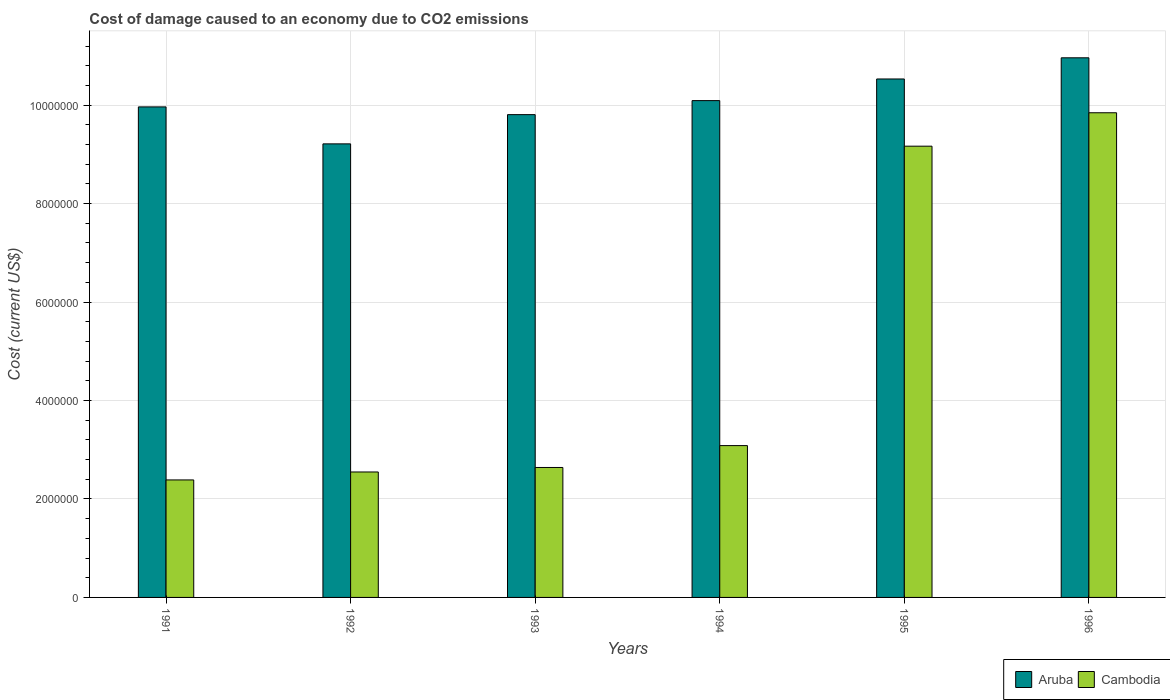How many different coloured bars are there?
Ensure brevity in your answer.  2. What is the label of the 1st group of bars from the left?
Provide a succinct answer. 1991. In how many cases, is the number of bars for a given year not equal to the number of legend labels?
Provide a short and direct response. 0. What is the cost of damage caused due to CO2 emissisons in Aruba in 1993?
Offer a terse response. 9.81e+06. Across all years, what is the maximum cost of damage caused due to CO2 emissisons in Cambodia?
Keep it short and to the point. 9.85e+06. Across all years, what is the minimum cost of damage caused due to CO2 emissisons in Cambodia?
Ensure brevity in your answer.  2.39e+06. In which year was the cost of damage caused due to CO2 emissisons in Cambodia minimum?
Offer a terse response. 1991. What is the total cost of damage caused due to CO2 emissisons in Cambodia in the graph?
Offer a very short reply. 2.97e+07. What is the difference between the cost of damage caused due to CO2 emissisons in Aruba in 1992 and that in 1993?
Give a very brief answer. -5.94e+05. What is the difference between the cost of damage caused due to CO2 emissisons in Aruba in 1992 and the cost of damage caused due to CO2 emissisons in Cambodia in 1994?
Ensure brevity in your answer.  6.13e+06. What is the average cost of damage caused due to CO2 emissisons in Aruba per year?
Keep it short and to the point. 1.01e+07. In the year 1994, what is the difference between the cost of damage caused due to CO2 emissisons in Cambodia and cost of damage caused due to CO2 emissisons in Aruba?
Give a very brief answer. -7.01e+06. What is the ratio of the cost of damage caused due to CO2 emissisons in Aruba in 1992 to that in 1995?
Offer a terse response. 0.87. Is the difference between the cost of damage caused due to CO2 emissisons in Cambodia in 1992 and 1994 greater than the difference between the cost of damage caused due to CO2 emissisons in Aruba in 1992 and 1994?
Your answer should be compact. Yes. What is the difference between the highest and the second highest cost of damage caused due to CO2 emissisons in Aruba?
Provide a short and direct response. 4.30e+05. What is the difference between the highest and the lowest cost of damage caused due to CO2 emissisons in Aruba?
Keep it short and to the point. 1.75e+06. What does the 1st bar from the left in 1992 represents?
Provide a succinct answer. Aruba. What does the 1st bar from the right in 1991 represents?
Your answer should be compact. Cambodia. How many bars are there?
Provide a succinct answer. 12. How many years are there in the graph?
Provide a succinct answer. 6. Does the graph contain any zero values?
Your response must be concise. No. Where does the legend appear in the graph?
Your response must be concise. Bottom right. How many legend labels are there?
Offer a very short reply. 2. What is the title of the graph?
Your answer should be very brief. Cost of damage caused to an economy due to CO2 emissions. What is the label or title of the X-axis?
Offer a very short reply. Years. What is the label or title of the Y-axis?
Provide a short and direct response. Cost (current US$). What is the Cost (current US$) in Aruba in 1991?
Offer a terse response. 9.96e+06. What is the Cost (current US$) in Cambodia in 1991?
Offer a terse response. 2.39e+06. What is the Cost (current US$) of Aruba in 1992?
Make the answer very short. 9.21e+06. What is the Cost (current US$) in Cambodia in 1992?
Give a very brief answer. 2.55e+06. What is the Cost (current US$) in Aruba in 1993?
Keep it short and to the point. 9.81e+06. What is the Cost (current US$) of Cambodia in 1993?
Your answer should be compact. 2.64e+06. What is the Cost (current US$) in Aruba in 1994?
Offer a very short reply. 1.01e+07. What is the Cost (current US$) of Cambodia in 1994?
Your answer should be very brief. 3.08e+06. What is the Cost (current US$) of Aruba in 1995?
Offer a terse response. 1.05e+07. What is the Cost (current US$) in Cambodia in 1995?
Ensure brevity in your answer.  9.17e+06. What is the Cost (current US$) of Aruba in 1996?
Your answer should be very brief. 1.10e+07. What is the Cost (current US$) of Cambodia in 1996?
Provide a succinct answer. 9.85e+06. Across all years, what is the maximum Cost (current US$) in Aruba?
Give a very brief answer. 1.10e+07. Across all years, what is the maximum Cost (current US$) in Cambodia?
Provide a short and direct response. 9.85e+06. Across all years, what is the minimum Cost (current US$) in Aruba?
Offer a very short reply. 9.21e+06. Across all years, what is the minimum Cost (current US$) of Cambodia?
Offer a terse response. 2.39e+06. What is the total Cost (current US$) in Aruba in the graph?
Offer a very short reply. 6.06e+07. What is the total Cost (current US$) of Cambodia in the graph?
Give a very brief answer. 2.97e+07. What is the difference between the Cost (current US$) of Aruba in 1991 and that in 1992?
Your answer should be compact. 7.51e+05. What is the difference between the Cost (current US$) in Cambodia in 1991 and that in 1992?
Ensure brevity in your answer.  -1.62e+05. What is the difference between the Cost (current US$) of Aruba in 1991 and that in 1993?
Your response must be concise. 1.57e+05. What is the difference between the Cost (current US$) of Cambodia in 1991 and that in 1993?
Keep it short and to the point. -2.53e+05. What is the difference between the Cost (current US$) of Aruba in 1991 and that in 1994?
Your answer should be very brief. -1.28e+05. What is the difference between the Cost (current US$) of Cambodia in 1991 and that in 1994?
Make the answer very short. -6.97e+05. What is the difference between the Cost (current US$) of Aruba in 1991 and that in 1995?
Ensure brevity in your answer.  -5.67e+05. What is the difference between the Cost (current US$) of Cambodia in 1991 and that in 1995?
Your answer should be very brief. -6.78e+06. What is the difference between the Cost (current US$) in Aruba in 1991 and that in 1996?
Your answer should be compact. -9.97e+05. What is the difference between the Cost (current US$) of Cambodia in 1991 and that in 1996?
Your answer should be very brief. -7.46e+06. What is the difference between the Cost (current US$) of Aruba in 1992 and that in 1993?
Provide a short and direct response. -5.94e+05. What is the difference between the Cost (current US$) in Cambodia in 1992 and that in 1993?
Offer a terse response. -9.13e+04. What is the difference between the Cost (current US$) of Aruba in 1992 and that in 1994?
Give a very brief answer. -8.78e+05. What is the difference between the Cost (current US$) in Cambodia in 1992 and that in 1994?
Offer a terse response. -5.36e+05. What is the difference between the Cost (current US$) of Aruba in 1992 and that in 1995?
Offer a very short reply. -1.32e+06. What is the difference between the Cost (current US$) in Cambodia in 1992 and that in 1995?
Give a very brief answer. -6.62e+06. What is the difference between the Cost (current US$) of Aruba in 1992 and that in 1996?
Provide a short and direct response. -1.75e+06. What is the difference between the Cost (current US$) of Cambodia in 1992 and that in 1996?
Provide a short and direct response. -7.30e+06. What is the difference between the Cost (current US$) in Aruba in 1993 and that in 1994?
Offer a terse response. -2.84e+05. What is the difference between the Cost (current US$) of Cambodia in 1993 and that in 1994?
Your answer should be very brief. -4.45e+05. What is the difference between the Cost (current US$) in Aruba in 1993 and that in 1995?
Offer a terse response. -7.24e+05. What is the difference between the Cost (current US$) in Cambodia in 1993 and that in 1995?
Offer a very short reply. -6.53e+06. What is the difference between the Cost (current US$) in Aruba in 1993 and that in 1996?
Your response must be concise. -1.15e+06. What is the difference between the Cost (current US$) in Cambodia in 1993 and that in 1996?
Your answer should be compact. -7.21e+06. What is the difference between the Cost (current US$) in Aruba in 1994 and that in 1995?
Ensure brevity in your answer.  -4.40e+05. What is the difference between the Cost (current US$) of Cambodia in 1994 and that in 1995?
Your response must be concise. -6.08e+06. What is the difference between the Cost (current US$) in Aruba in 1994 and that in 1996?
Provide a short and direct response. -8.70e+05. What is the difference between the Cost (current US$) in Cambodia in 1994 and that in 1996?
Keep it short and to the point. -6.76e+06. What is the difference between the Cost (current US$) of Aruba in 1995 and that in 1996?
Your response must be concise. -4.30e+05. What is the difference between the Cost (current US$) in Cambodia in 1995 and that in 1996?
Keep it short and to the point. -6.79e+05. What is the difference between the Cost (current US$) in Aruba in 1991 and the Cost (current US$) in Cambodia in 1992?
Offer a very short reply. 7.42e+06. What is the difference between the Cost (current US$) of Aruba in 1991 and the Cost (current US$) of Cambodia in 1993?
Offer a terse response. 7.32e+06. What is the difference between the Cost (current US$) of Aruba in 1991 and the Cost (current US$) of Cambodia in 1994?
Your response must be concise. 6.88e+06. What is the difference between the Cost (current US$) in Aruba in 1991 and the Cost (current US$) in Cambodia in 1995?
Give a very brief answer. 7.98e+05. What is the difference between the Cost (current US$) in Aruba in 1991 and the Cost (current US$) in Cambodia in 1996?
Your answer should be compact. 1.19e+05. What is the difference between the Cost (current US$) of Aruba in 1992 and the Cost (current US$) of Cambodia in 1993?
Offer a terse response. 6.57e+06. What is the difference between the Cost (current US$) of Aruba in 1992 and the Cost (current US$) of Cambodia in 1994?
Provide a short and direct response. 6.13e+06. What is the difference between the Cost (current US$) in Aruba in 1992 and the Cost (current US$) in Cambodia in 1995?
Your answer should be compact. 4.69e+04. What is the difference between the Cost (current US$) in Aruba in 1992 and the Cost (current US$) in Cambodia in 1996?
Your response must be concise. -6.32e+05. What is the difference between the Cost (current US$) of Aruba in 1993 and the Cost (current US$) of Cambodia in 1994?
Your answer should be very brief. 6.72e+06. What is the difference between the Cost (current US$) in Aruba in 1993 and the Cost (current US$) in Cambodia in 1995?
Offer a very short reply. 6.41e+05. What is the difference between the Cost (current US$) of Aruba in 1993 and the Cost (current US$) of Cambodia in 1996?
Make the answer very short. -3.80e+04. What is the difference between the Cost (current US$) of Aruba in 1994 and the Cost (current US$) of Cambodia in 1995?
Ensure brevity in your answer.  9.25e+05. What is the difference between the Cost (current US$) in Aruba in 1994 and the Cost (current US$) in Cambodia in 1996?
Offer a terse response. 2.46e+05. What is the difference between the Cost (current US$) in Aruba in 1995 and the Cost (current US$) in Cambodia in 1996?
Your answer should be very brief. 6.86e+05. What is the average Cost (current US$) in Aruba per year?
Give a very brief answer. 1.01e+07. What is the average Cost (current US$) in Cambodia per year?
Keep it short and to the point. 4.95e+06. In the year 1991, what is the difference between the Cost (current US$) of Aruba and Cost (current US$) of Cambodia?
Your response must be concise. 7.58e+06. In the year 1992, what is the difference between the Cost (current US$) of Aruba and Cost (current US$) of Cambodia?
Give a very brief answer. 6.66e+06. In the year 1993, what is the difference between the Cost (current US$) in Aruba and Cost (current US$) in Cambodia?
Give a very brief answer. 7.17e+06. In the year 1994, what is the difference between the Cost (current US$) of Aruba and Cost (current US$) of Cambodia?
Offer a very short reply. 7.01e+06. In the year 1995, what is the difference between the Cost (current US$) of Aruba and Cost (current US$) of Cambodia?
Offer a very short reply. 1.37e+06. In the year 1996, what is the difference between the Cost (current US$) of Aruba and Cost (current US$) of Cambodia?
Offer a terse response. 1.12e+06. What is the ratio of the Cost (current US$) in Aruba in 1991 to that in 1992?
Provide a short and direct response. 1.08. What is the ratio of the Cost (current US$) of Cambodia in 1991 to that in 1992?
Provide a short and direct response. 0.94. What is the ratio of the Cost (current US$) in Cambodia in 1991 to that in 1993?
Give a very brief answer. 0.9. What is the ratio of the Cost (current US$) of Aruba in 1991 to that in 1994?
Provide a succinct answer. 0.99. What is the ratio of the Cost (current US$) of Cambodia in 1991 to that in 1994?
Keep it short and to the point. 0.77. What is the ratio of the Cost (current US$) of Aruba in 1991 to that in 1995?
Your response must be concise. 0.95. What is the ratio of the Cost (current US$) in Cambodia in 1991 to that in 1995?
Your answer should be compact. 0.26. What is the ratio of the Cost (current US$) of Aruba in 1991 to that in 1996?
Give a very brief answer. 0.91. What is the ratio of the Cost (current US$) in Cambodia in 1991 to that in 1996?
Offer a very short reply. 0.24. What is the ratio of the Cost (current US$) in Aruba in 1992 to that in 1993?
Provide a short and direct response. 0.94. What is the ratio of the Cost (current US$) in Cambodia in 1992 to that in 1993?
Offer a very short reply. 0.97. What is the ratio of the Cost (current US$) of Aruba in 1992 to that in 1994?
Make the answer very short. 0.91. What is the ratio of the Cost (current US$) in Cambodia in 1992 to that in 1994?
Keep it short and to the point. 0.83. What is the ratio of the Cost (current US$) of Aruba in 1992 to that in 1995?
Your answer should be very brief. 0.87. What is the ratio of the Cost (current US$) in Cambodia in 1992 to that in 1995?
Offer a terse response. 0.28. What is the ratio of the Cost (current US$) of Aruba in 1992 to that in 1996?
Your response must be concise. 0.84. What is the ratio of the Cost (current US$) in Cambodia in 1992 to that in 1996?
Give a very brief answer. 0.26. What is the ratio of the Cost (current US$) of Aruba in 1993 to that in 1994?
Ensure brevity in your answer.  0.97. What is the ratio of the Cost (current US$) in Cambodia in 1993 to that in 1994?
Ensure brevity in your answer.  0.86. What is the ratio of the Cost (current US$) of Aruba in 1993 to that in 1995?
Provide a succinct answer. 0.93. What is the ratio of the Cost (current US$) of Cambodia in 1993 to that in 1995?
Provide a short and direct response. 0.29. What is the ratio of the Cost (current US$) of Aruba in 1993 to that in 1996?
Your answer should be compact. 0.89. What is the ratio of the Cost (current US$) in Cambodia in 1993 to that in 1996?
Give a very brief answer. 0.27. What is the ratio of the Cost (current US$) in Aruba in 1994 to that in 1995?
Your answer should be very brief. 0.96. What is the ratio of the Cost (current US$) of Cambodia in 1994 to that in 1995?
Keep it short and to the point. 0.34. What is the ratio of the Cost (current US$) in Aruba in 1994 to that in 1996?
Your answer should be very brief. 0.92. What is the ratio of the Cost (current US$) of Cambodia in 1994 to that in 1996?
Provide a succinct answer. 0.31. What is the ratio of the Cost (current US$) of Aruba in 1995 to that in 1996?
Ensure brevity in your answer.  0.96. What is the ratio of the Cost (current US$) in Cambodia in 1995 to that in 1996?
Provide a short and direct response. 0.93. What is the difference between the highest and the second highest Cost (current US$) of Aruba?
Offer a terse response. 4.30e+05. What is the difference between the highest and the second highest Cost (current US$) in Cambodia?
Give a very brief answer. 6.79e+05. What is the difference between the highest and the lowest Cost (current US$) of Aruba?
Your answer should be very brief. 1.75e+06. What is the difference between the highest and the lowest Cost (current US$) in Cambodia?
Provide a succinct answer. 7.46e+06. 